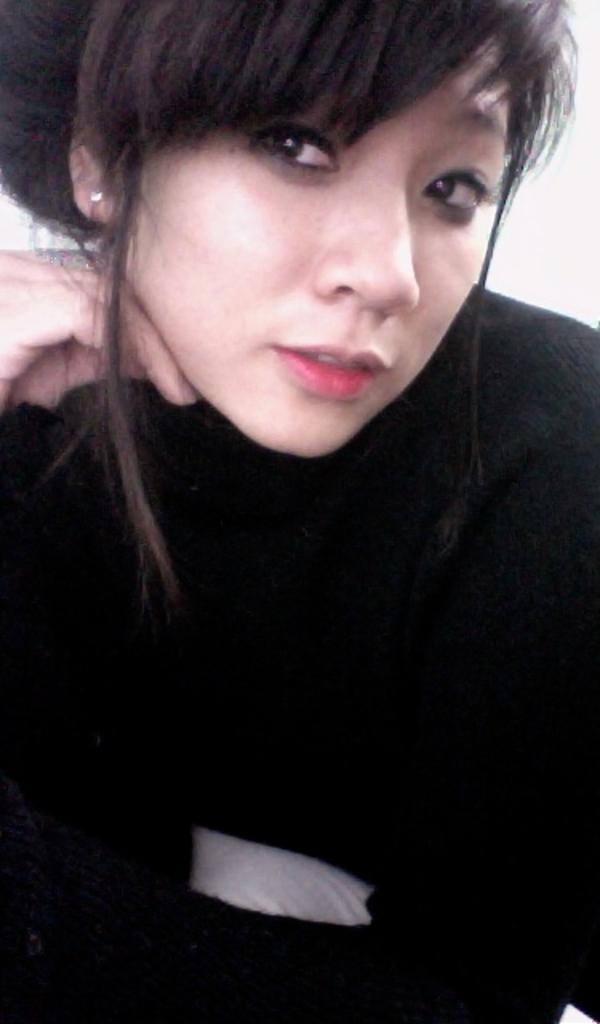How would you summarize this image in a sentence or two? In this image there is woman, she is wearing black color T-shirt. 